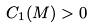Convert formula to latex. <formula><loc_0><loc_0><loc_500><loc_500>C _ { 1 } ( M ) > 0</formula> 